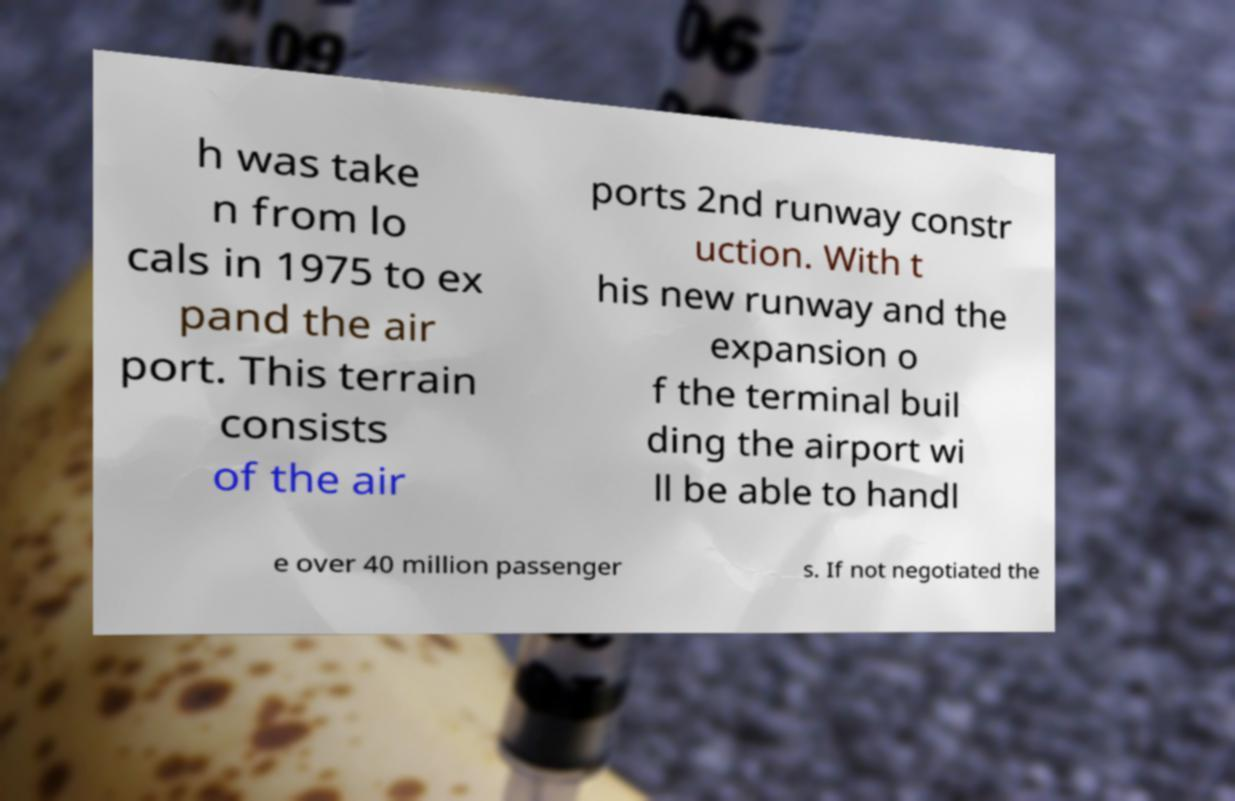Could you assist in decoding the text presented in this image and type it out clearly? h was take n from lo cals in 1975 to ex pand the air port. This terrain consists of the air ports 2nd runway constr uction. With t his new runway and the expansion o f the terminal buil ding the airport wi ll be able to handl e over 40 million passenger s. If not negotiated the 